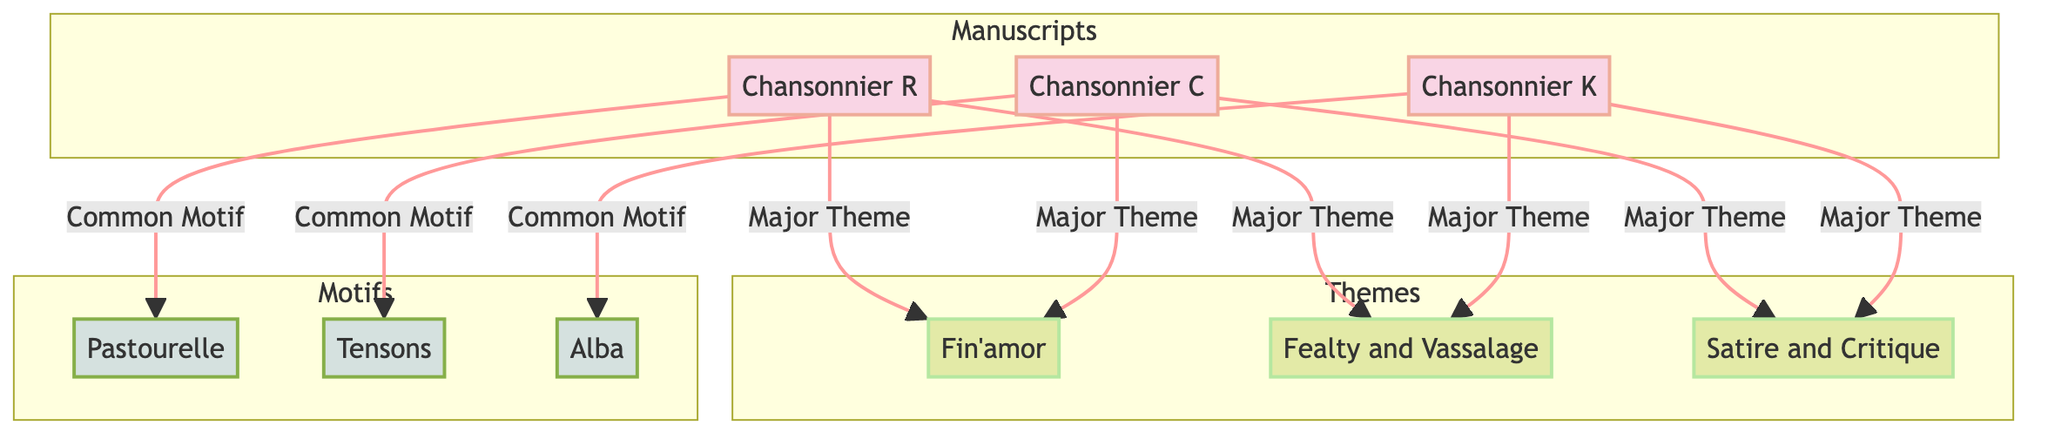What are the three manuscripts represented in the diagram? The diagram displays three manuscripts: Chansonnier R, Chansonnier C, and Chansonnier K. These can be identified as nodes under the "Manuscripts" subgraph.
Answer: Chansonnier R, Chansonnier C, Chansonnier K Which major theme is present in Chansonnier R? Chansonnier R is connected to two major themes, one of which is Fin'amor. This information can be seen from the edge connecting M1 to T1.
Answer: Fin'amor How many common motifs are associated with Chansonnier C? Chansonnier C has one common motif as indicated by the arrow leading from M2 to MT2. No other motifs are directly connected to it.
Answer: 1 Which major theme is shared between Chansonnier K and Chansonnier C? Both Chansonnier K and Chansonnier C share the major theme Satire and Critique. This can be deduced by examining the connections of both manuscripts to the same theme node, T3.
Answer: Satire and Critique What unique motif is found in Chansonnier K? Chansonnier K is associated with the common motif Alba, as shown by the connection between M3 and MT3. It is the only motif linked with this manuscript.
Answer: Alba How many major themes are represented in total across the manuscripts? The diagram depicts three unique major themes: Fin'amor, Fealty and Vassalage, and Satire and Critique. These themes are connected to different manuscripts, so counting them gives a total of three.
Answer: 3 Which major theme is missing from Chansonnier C? By analyzing the connections, it can be observed that the major theme Fealty and Vassalage is not linked to Chansonnier C, as this theme is only connected to Chansonnier R and K.
Answer: Fealty and Vassalage What is the relationship between the motifs and themes in any given manuscript? Each manuscript is connected to one or more major themes and may have one common motif associated with them. The connections show distinct themes and motifs linked to various manuscripts.
Answer: Major theme to common motif relationship Which manuscript focuses on satire and critique as a major theme? Chansonnier C and Chansonnier K both focus on Satire and Critique as a major theme. This is evident from their respective connections to the T3 theme node.
Answer: Chansonnier C, Chansonnier K 